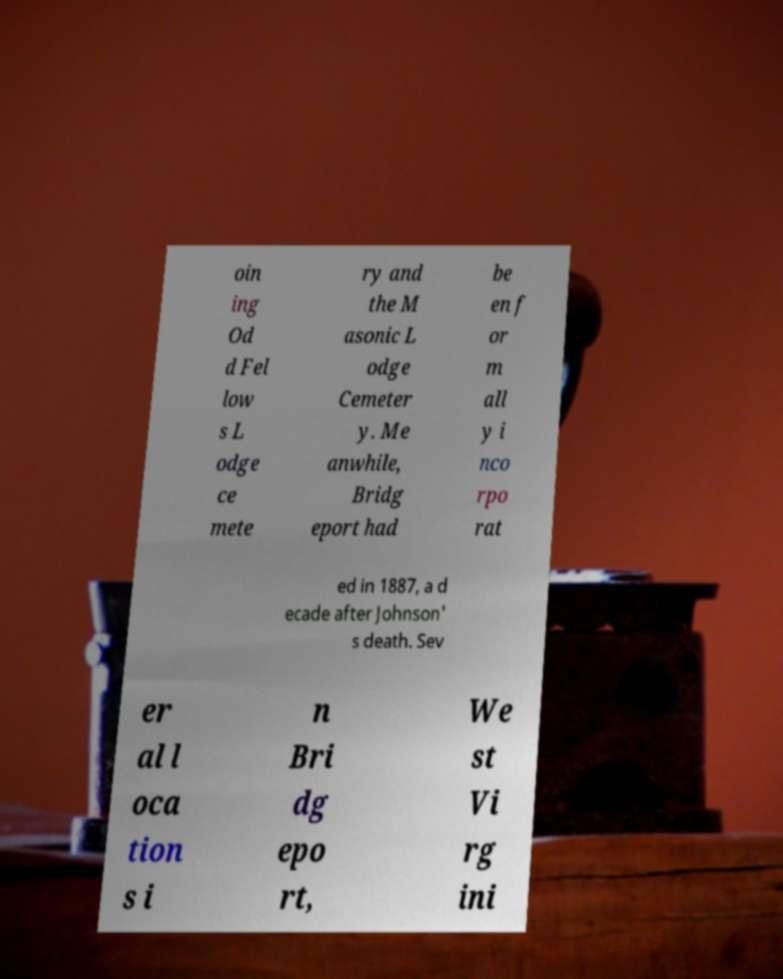Could you extract and type out the text from this image? oin ing Od d Fel low s L odge ce mete ry and the M asonic L odge Cemeter y. Me anwhile, Bridg eport had be en f or m all y i nco rpo rat ed in 1887, a d ecade after Johnson' s death. Sev er al l oca tion s i n Bri dg epo rt, We st Vi rg ini 